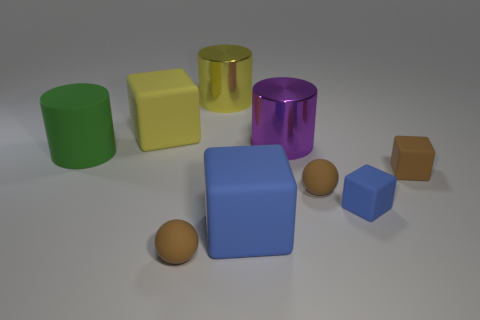Add 1 small brown balls. How many objects exist? 10 Subtract all cylinders. How many objects are left? 6 Subtract all small blue objects. Subtract all yellow rubber cubes. How many objects are left? 7 Add 1 tiny matte objects. How many tiny matte objects are left? 5 Add 8 large yellow rubber objects. How many large yellow rubber objects exist? 9 Subtract 0 yellow spheres. How many objects are left? 9 